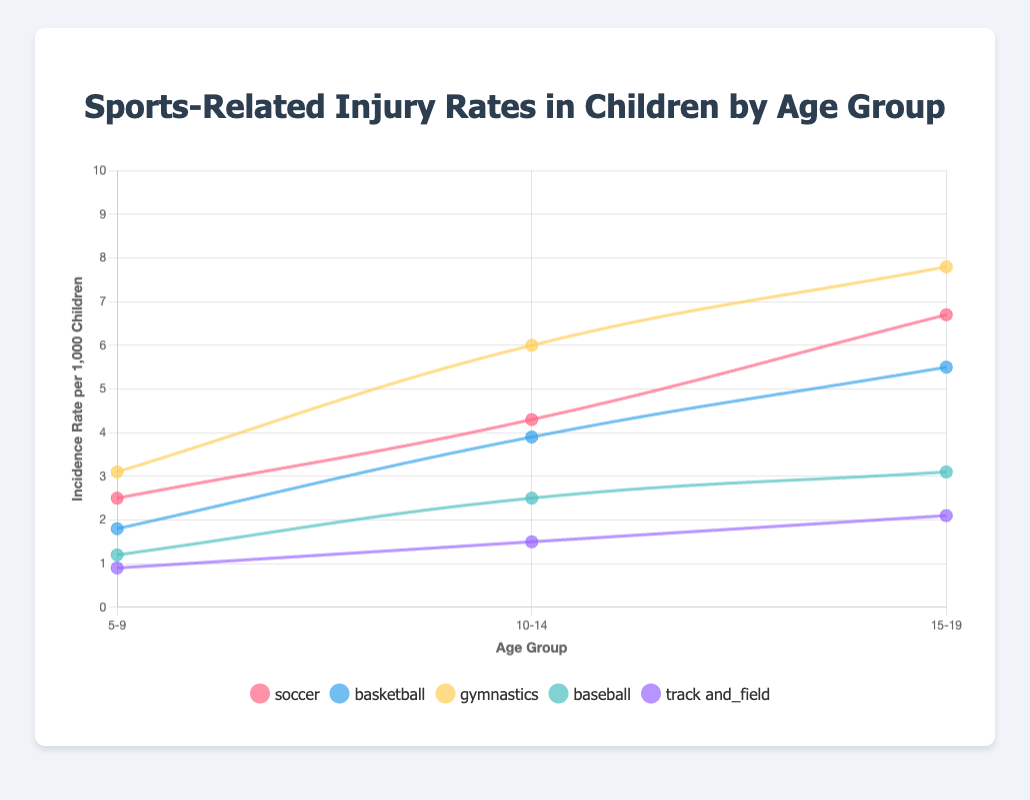What is the incidence rate of gymnastics-related injuries for the 10-14 age group? Look at the value on the gymnastics line where it intersects with the 10-14 age group on the x-axis; it shows 6.0 injuries per 1,000 children.
Answer: 6.0 Which sport has the highest incidence rate of injuries in the 5-9 age group? Compare the values of all sports for the 5-9 age group; gymnastics has the highest incidence rate at 3.1 per 1,000 children.
Answer: Gymnastics By how much does the incidence rate of soccer injuries increase from the 10-14 age group to the 15-19 age group? Identify the incidence rate of soccer for both age groups (4.3 for 10-14 and 6.7 for 15-19) and calculate the difference: 6.7 - 4.3 = 2.4.
Answer: 2.4 Which sport shows the least increase in injury incidence rates from the 5-9 age group to the 15-19 age group? Calculate the difference in incidence rates for each sport between these two age groups, and compare to find the least increase:
- Soccer: 6.7 - 2.5 = 4.2
- Basketball: 5.5 - 1.8 = 3.7
- Gymnastics: 7.8 - 3.1 = 4.7
- Baseball: 3.1 - 1.2 = 1.9
- Track and Field: 2.1 - 0.9 = 1.2.
Answer: Track and Field Which sport has the highest overall increase in incidence rate from the 5-19 age groups? Calculate the change in incidence rates from 5-9 to 15-19 and compare:
- Soccer: 6.7 - 2.5 = 4.2
- Basketball: 5.5 - 1.8 = 3.7
- Gymnastics: 7.8 - 3.1 = 4.7
- Baseball: 3.1 - 1.2 = 1.9
- Track and Field: 2.1 - 0.9 = 1.2
Gymnastics has the highest increase.
Answer: Gymnastics By how much does the incidence rate of gymnastics-related injuries increase from 5-14 age group to 15-19 age group? Identify the incidence rate of gymnastics for both 5-14 and 15-19:
- For 5-9: 3.1
- For 10-14: 6.0
- Average incidence rate for 5-14: (3.1 + 6.0)/2 = 4.55
- Increase from 5-14 to 15-19: 7.8 - 4.55 = 3.25.
Answer: 3.25 Which age group has the highest incidence rate for soccer-related injuries? Look at the incidence rate of soccer at each age group and compare: 2.5 for 5-9, 4.3 for 10-14, and 6.7 for 15-19. The highest is 6.7 for 15-19.
Answer: 15-19 What is the average incidence rate of injuries for track and field for all age groups? Sum the incidence rates of track and field for each age group and divide by the number of age groups (0.9 + 1.5 + 2.1):
0.9 + 1.5 + 2.1 = 4.5. 
Average: 4.5 / 3 = 1.5.
Answer: 1.5 Which sport has the steadiest increase in incidence rates across all age groups? Compare the rates of increase between the age groups for each sport:
- Soccer: 2.5 -> 4.3 -> 6.7 (Increase: 4.2)
- Basketball: 1.8 -> 3.9 -> 5.5 (Increase: 3.7)
- Gymnastics: 3.1 -> 6.0 -> 7.8 (Increase: 4.7)
- Baseball: 1.2 -> 2.5 -> 3.1 (Increase: 1.9)
- Track and Field: 0.9 -> 1.5 -> 2.1 (Increase: 1.2)
Track and Field has the smallest average increase, indicating the steadiest rise.
Answer: Track and Field 